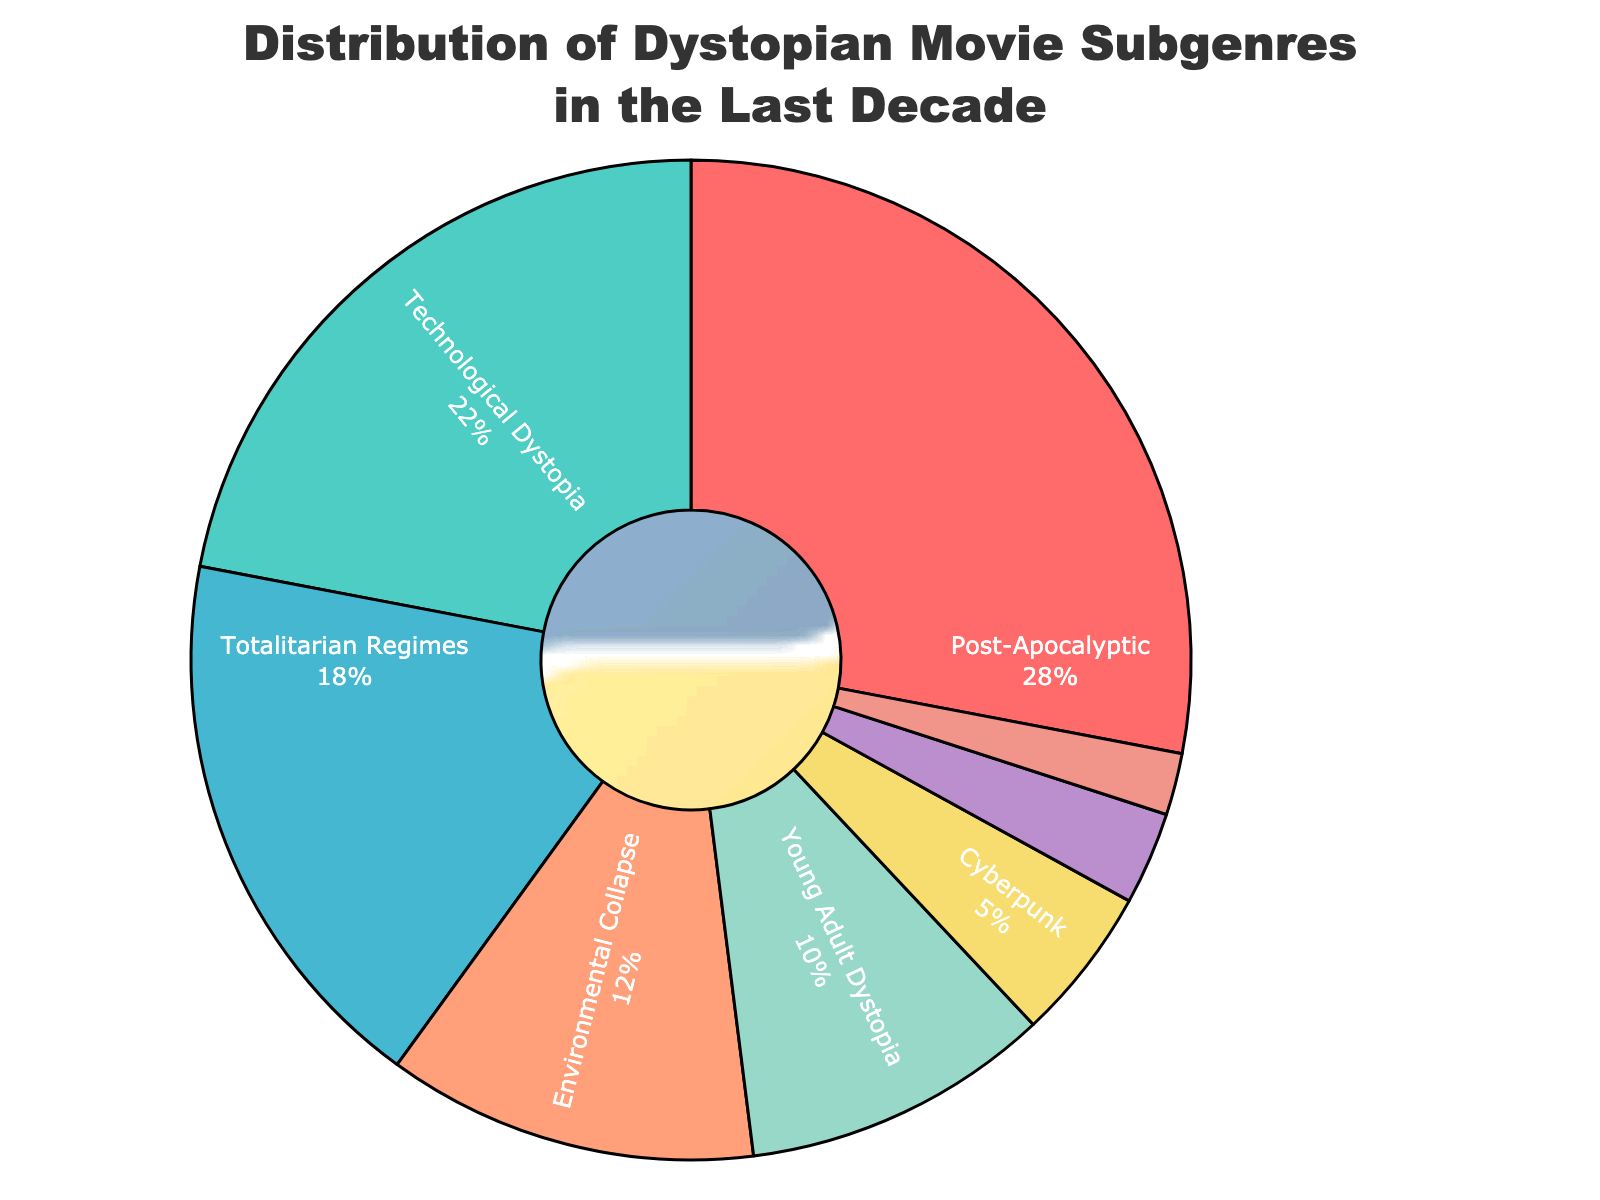Which subgenre has the highest percentage? The figure displays a pie chart with various sections representing different subgenres and their respective percentages. The largest section is labeled "Post-Apocalyptic" with a percentage of 28%.
Answer: Post-Apocalyptic Which subgenres together make up over 40% of the distribution? By observing the percentages of each subgenre in the pie chart, we add the two highest percentages: Post-Apocalyptic (28%) and Technological Dystopia (22%), which sum up to 50%, surpassing 40%.
Answer: Post-Apocalyptic and Technological Dystopia How much more prevalent is the "Environmental Collapse" subgenre compared to "Pandemic-Related"? We subtract the percentage of the "Pandemic-Related" subgenre (2%) from the "Environmental Collapse" subgenre (12%).
Answer: 10% Which subgenre is the least represented in the distribution? By examining the pie chart, the smallest section corresponds to the "Pandemic-Related" subgenre, which has the least percentage (2%).
Answer: Pandemic-Related Is the sum of the percentages for "Totalitarian Regimes," "Young Adult Dystopia," and "Cyberpunk" greater than the percentage for "Post-Apocalyptic"? Adding the percentages of "Totalitarian Regimes" (18%), "Young Adult Dystopia" (10%), and "Cyberpunk" (5%) totals 33%, which is greater than the 28% of "Post-Apocalyptic".
Answer: Yes What is the combined percentage of subgenres that individually contribute less than 10%? The subgenres with less than 10% are: Cyberpunk (5%), Alternate History (3%), and Pandemic-Related (2%). Summing these percentages gives 5% + 3% + 2% = 10%.
Answer: 10% Between "Technological Dystopia" and "Young Adult Dystopia," which subgenre has more representation, and by how much? Comparing the percentages, "Technological Dystopia" has 22% while "Young Adult Dystopia" has 10%. The difference is 22% - 10% = 12%.
Answer: Technological Dystopia by 12% What percentage do the smallest three subgenres contribute combined? The smallest three subgenres are: Cyberpunk (5%), Alternate History (3%), and Pandemic-Related (2%). Adding these gives 5% + 3% + 2% = 10%.
Answer: 10% 